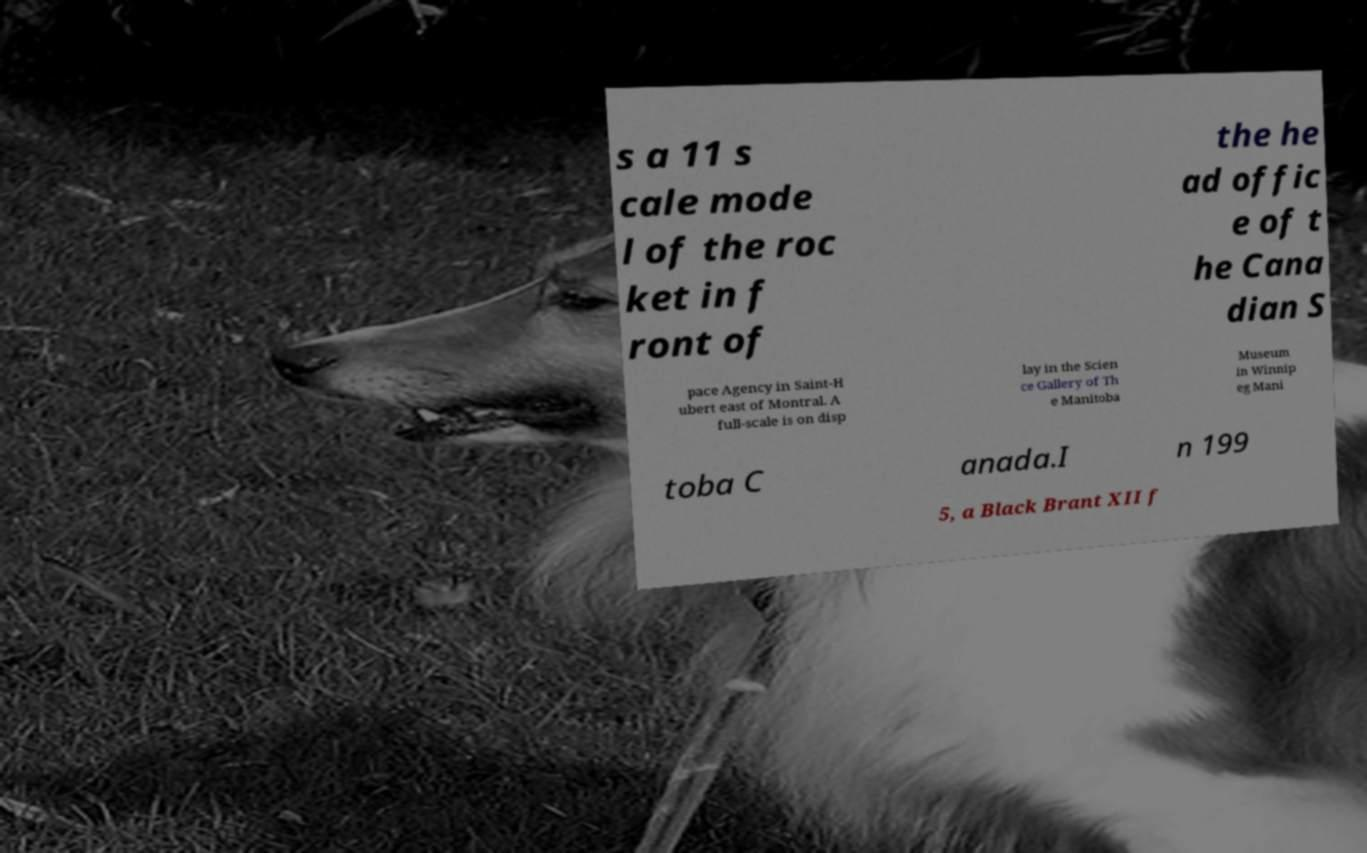Please read and relay the text visible in this image. What does it say? s a 11 s cale mode l of the roc ket in f ront of the he ad offic e of t he Cana dian S pace Agency in Saint-H ubert east of Montral. A full-scale is on disp lay in the Scien ce Gallery of Th e Manitoba Museum in Winnip eg Mani toba C anada.I n 199 5, a Black Brant XII f 